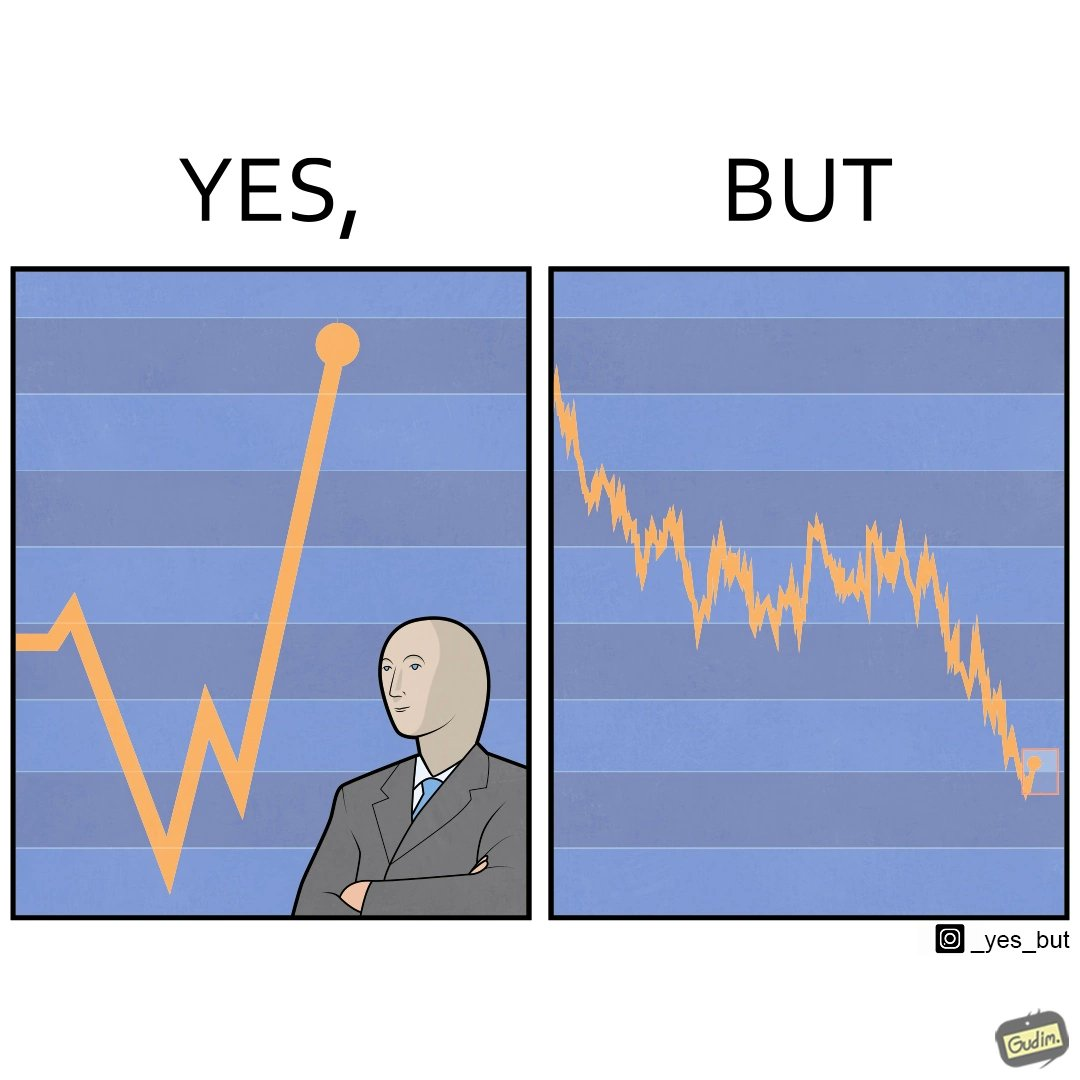Describe what you see in this image. The image is ironic, because a person is seen feeling proud over the profit earned over his investment but the right image shows the whole story how only a small part of his investment journey is shown and the other loss part is ignored 